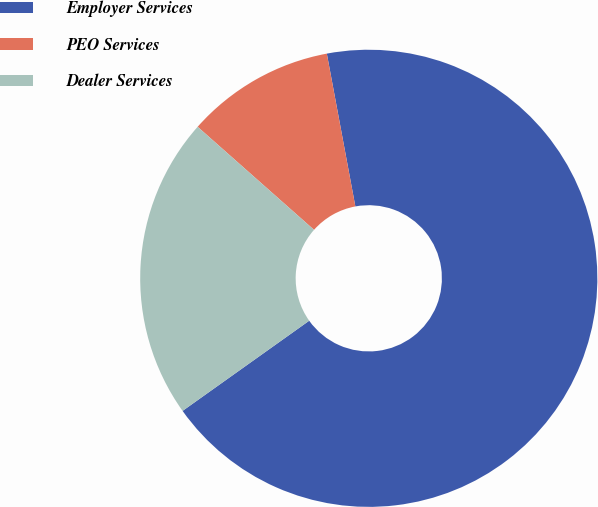<chart> <loc_0><loc_0><loc_500><loc_500><pie_chart><fcel>Employer Services<fcel>PEO Services<fcel>Dealer Services<nl><fcel>68.09%<fcel>10.53%<fcel>21.38%<nl></chart> 